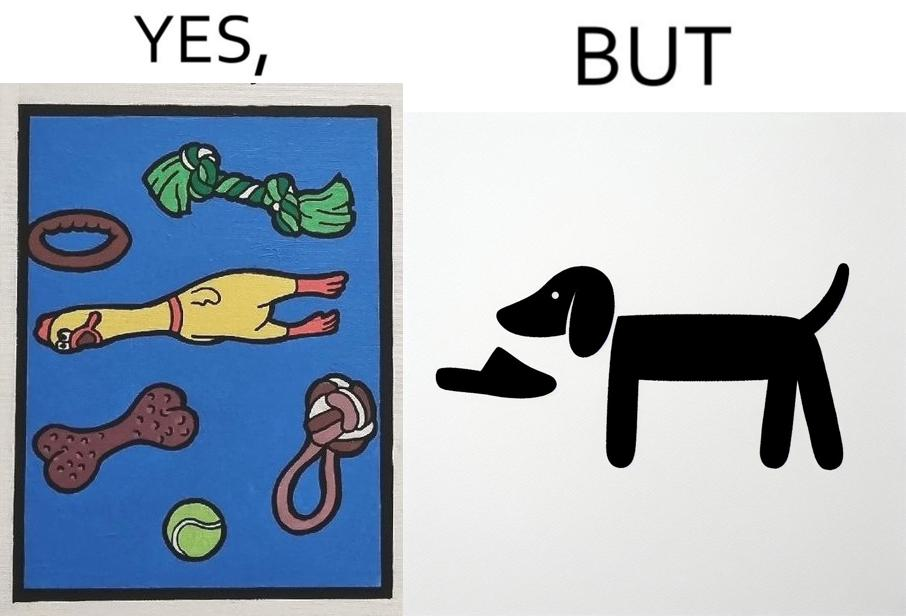What do you see in each half of this image? In the left part of the image: a bunch of toys In the right part of the image: a dog holding a slipper 